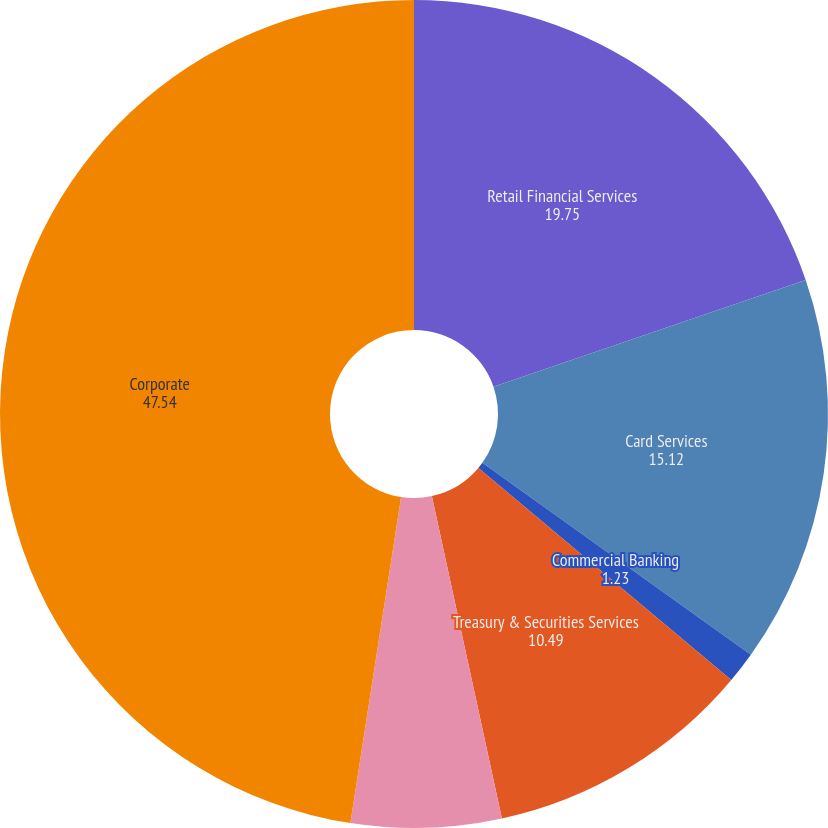Convert chart. <chart><loc_0><loc_0><loc_500><loc_500><pie_chart><fcel>Retail Financial Services<fcel>Card Services<fcel>Commercial Banking<fcel>Treasury & Securities Services<fcel>Asset Management<fcel>Corporate<nl><fcel>19.75%<fcel>15.12%<fcel>1.23%<fcel>10.49%<fcel>5.86%<fcel>47.54%<nl></chart> 